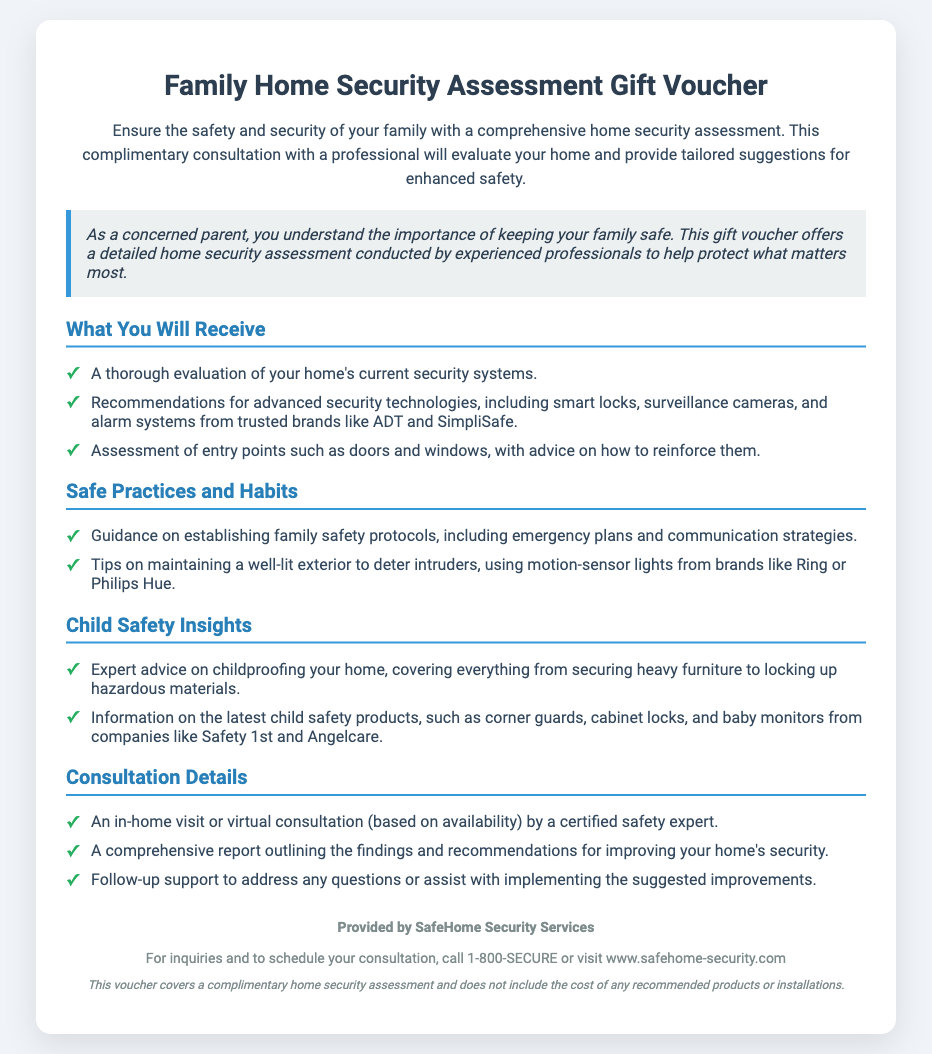What is the title of the voucher? The title of the voucher is prominently displayed at the top of the document.
Answer: Family Home Security Assessment Gift Voucher What company provides this service? The company name is listed in the footer section of the document.
Answer: SafeHome Security Services What are the two types of consultations offered? The types of consultations are mentioned in the "Consultation Details" section.
Answer: In-home visit or virtual consultation Which security brands are mentioned for recommendations? The document lists specific brands in the "What You Will Receive" section.
Answer: ADT and SimpliSafe What is the main focus of the consultation? The purpose of the consultation is summarized in the description at the beginning of the document.
Answer: Home security assessment What does the voucher cover? The limitations of the voucher are stated in the disclaimer at the end of the document.
Answer: Complimentary home security assessment What specific child safety insights are provided? The document details advice on child safety in the relevant section.
Answer: Expert advice on childproofing your home How can one schedule the consultation? The method for scheduling is provided in the footer of the document.
Answer: Call 1-800-SECURE or visit www.safehome-security.com 